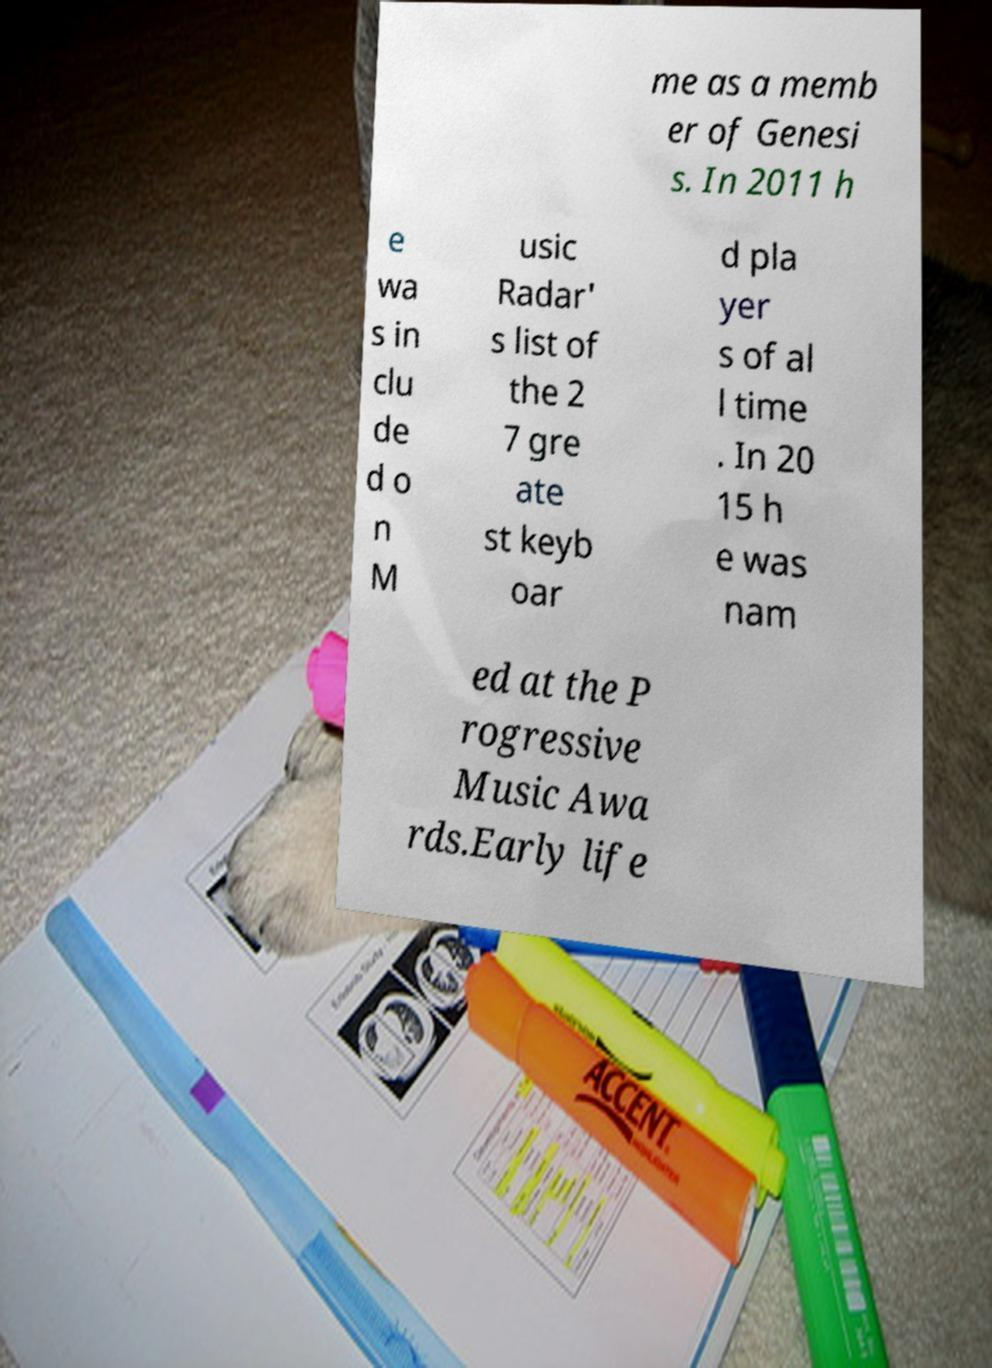Can you read and provide the text displayed in the image?This photo seems to have some interesting text. Can you extract and type it out for me? me as a memb er of Genesi s. In 2011 h e wa s in clu de d o n M usic Radar' s list of the 2 7 gre ate st keyb oar d pla yer s of al l time . In 20 15 h e was nam ed at the P rogressive Music Awa rds.Early life 